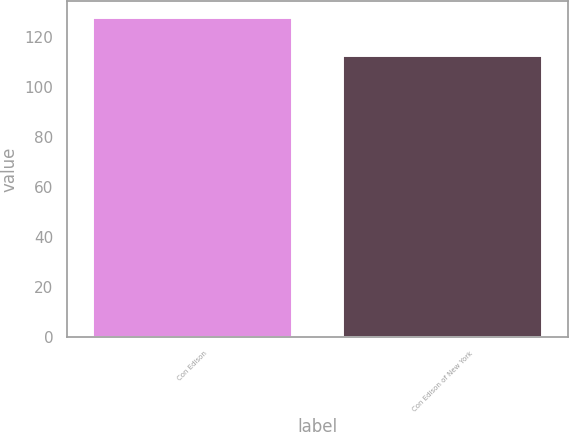Convert chart to OTSL. <chart><loc_0><loc_0><loc_500><loc_500><bar_chart><fcel>Con Edison<fcel>Con Edison of New York<nl><fcel>128<fcel>113<nl></chart> 